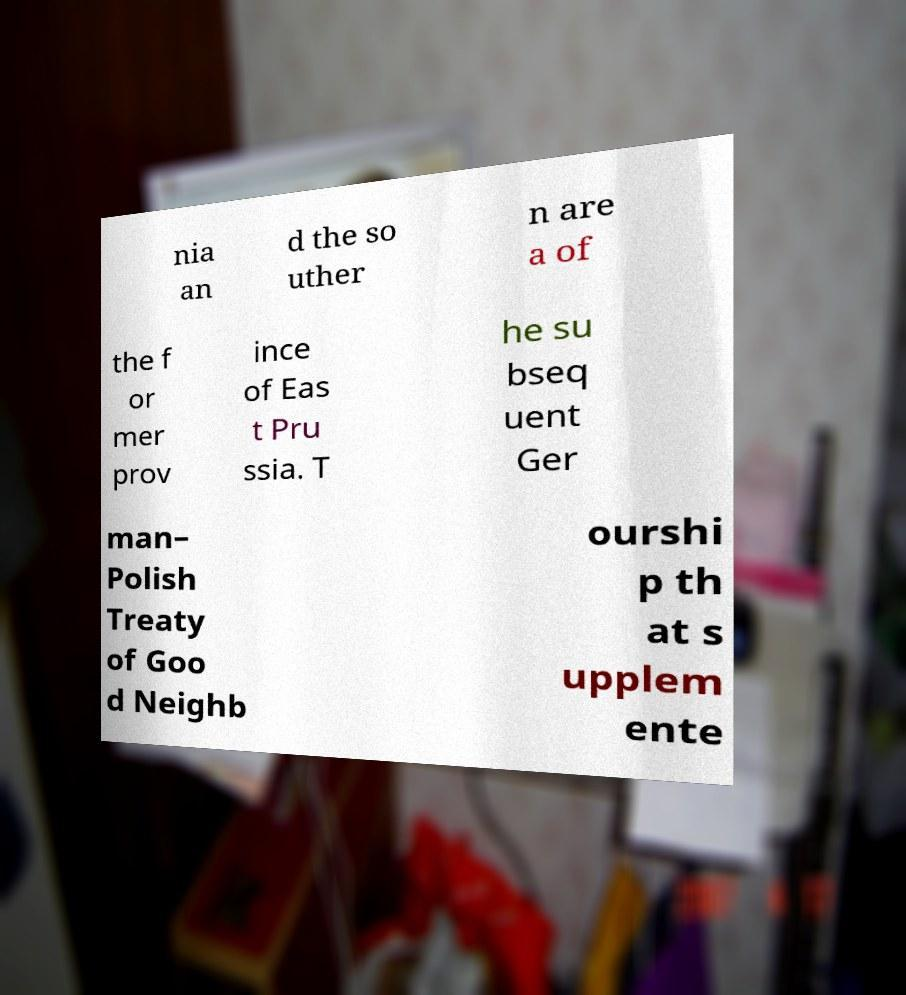For documentation purposes, I need the text within this image transcribed. Could you provide that? nia an d the so uther n are a of the f or mer prov ince of Eas t Pru ssia. T he su bseq uent Ger man– Polish Treaty of Goo d Neighb ourshi p th at s upplem ente 